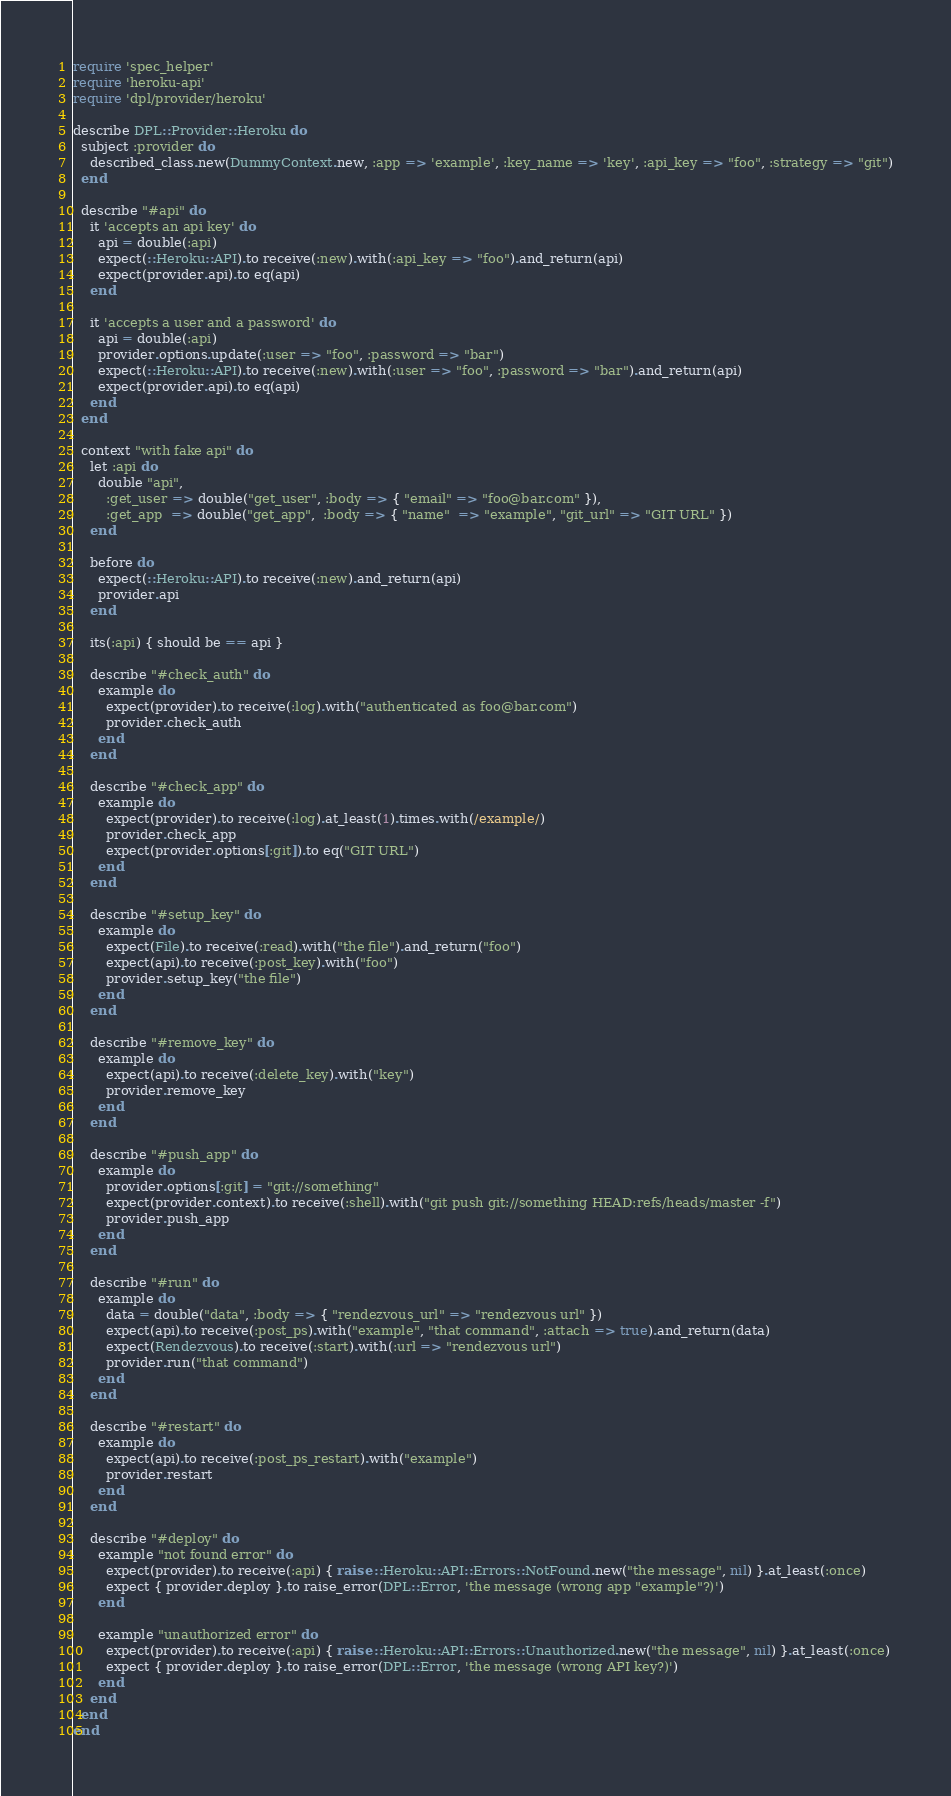<code> <loc_0><loc_0><loc_500><loc_500><_Ruby_>require 'spec_helper'
require 'heroku-api'
require 'dpl/provider/heroku'

describe DPL::Provider::Heroku do
  subject :provider do
    described_class.new(DummyContext.new, :app => 'example', :key_name => 'key', :api_key => "foo", :strategy => "git")
  end

  describe "#api" do
    it 'accepts an api key' do
      api = double(:api)
      expect(::Heroku::API).to receive(:new).with(:api_key => "foo").and_return(api)
      expect(provider.api).to eq(api)
    end

    it 'accepts a user and a password' do
      api = double(:api)
      provider.options.update(:user => "foo", :password => "bar")
      expect(::Heroku::API).to receive(:new).with(:user => "foo", :password => "bar").and_return(api)
      expect(provider.api).to eq(api)
    end
  end

  context "with fake api" do
    let :api do
      double "api",
        :get_user => double("get_user", :body => { "email" => "foo@bar.com" }),
        :get_app  => double("get_app",  :body => { "name"  => "example", "git_url" => "GIT URL" })
    end

    before do
      expect(::Heroku::API).to receive(:new).and_return(api)
      provider.api
    end

    its(:api) { should be == api }

    describe "#check_auth" do
      example do
        expect(provider).to receive(:log).with("authenticated as foo@bar.com")
        provider.check_auth
      end
    end

    describe "#check_app" do
      example do
        expect(provider).to receive(:log).at_least(1).times.with(/example/)
        provider.check_app
        expect(provider.options[:git]).to eq("GIT URL")
      end
    end

    describe "#setup_key" do
      example do
        expect(File).to receive(:read).with("the file").and_return("foo")
        expect(api).to receive(:post_key).with("foo")
        provider.setup_key("the file")
      end
    end

    describe "#remove_key" do
      example do
        expect(api).to receive(:delete_key).with("key")
        provider.remove_key
      end
    end

    describe "#push_app" do
      example do
        provider.options[:git] = "git://something"
        expect(provider.context).to receive(:shell).with("git push git://something HEAD:refs/heads/master -f")
        provider.push_app
      end
    end

    describe "#run" do
      example do
        data = double("data", :body => { "rendezvous_url" => "rendezvous url" })
        expect(api).to receive(:post_ps).with("example", "that command", :attach => true).and_return(data)
        expect(Rendezvous).to receive(:start).with(:url => "rendezvous url")
        provider.run("that command")
      end
    end

    describe "#restart" do
      example do
        expect(api).to receive(:post_ps_restart).with("example")
        provider.restart
      end
    end

    describe "#deploy" do
      example "not found error" do
        expect(provider).to receive(:api) { raise ::Heroku::API::Errors::NotFound.new("the message", nil) }.at_least(:once)
        expect { provider.deploy }.to raise_error(DPL::Error, 'the message (wrong app "example"?)')
      end

      example "unauthorized error" do
        expect(provider).to receive(:api) { raise ::Heroku::API::Errors::Unauthorized.new("the message", nil) }.at_least(:once)
        expect { provider.deploy }.to raise_error(DPL::Error, 'the message (wrong API key?)')
      end
    end
  end
end
</code> 